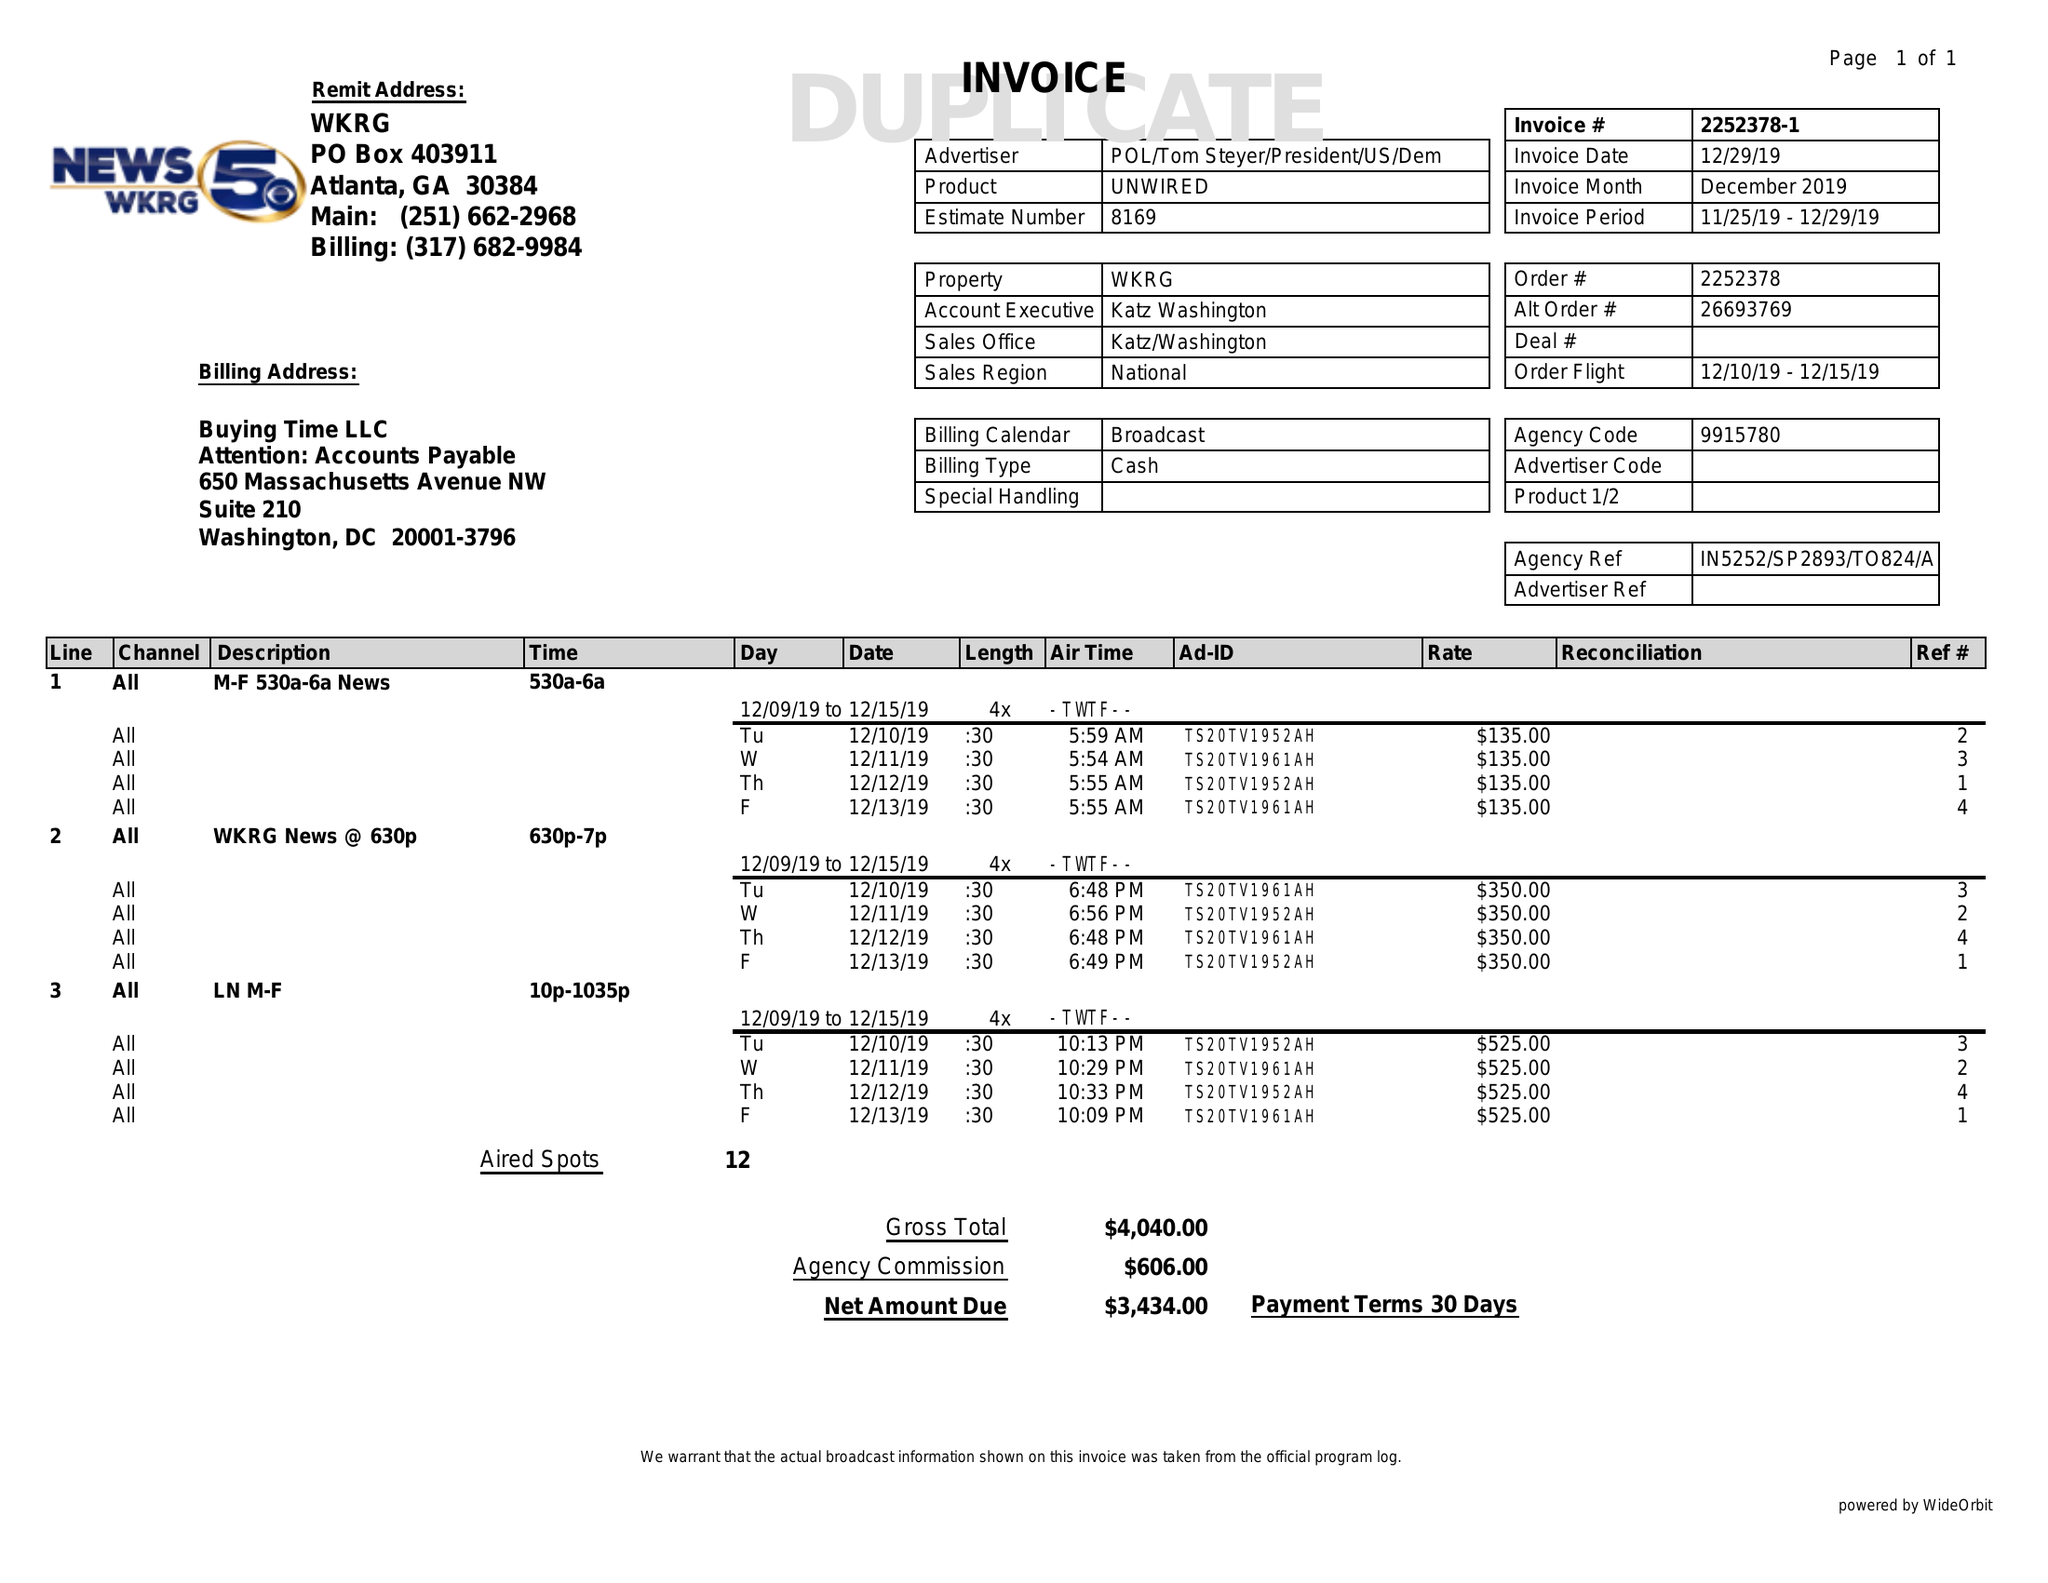What is the value for the gross_amount?
Answer the question using a single word or phrase. 4040.00 